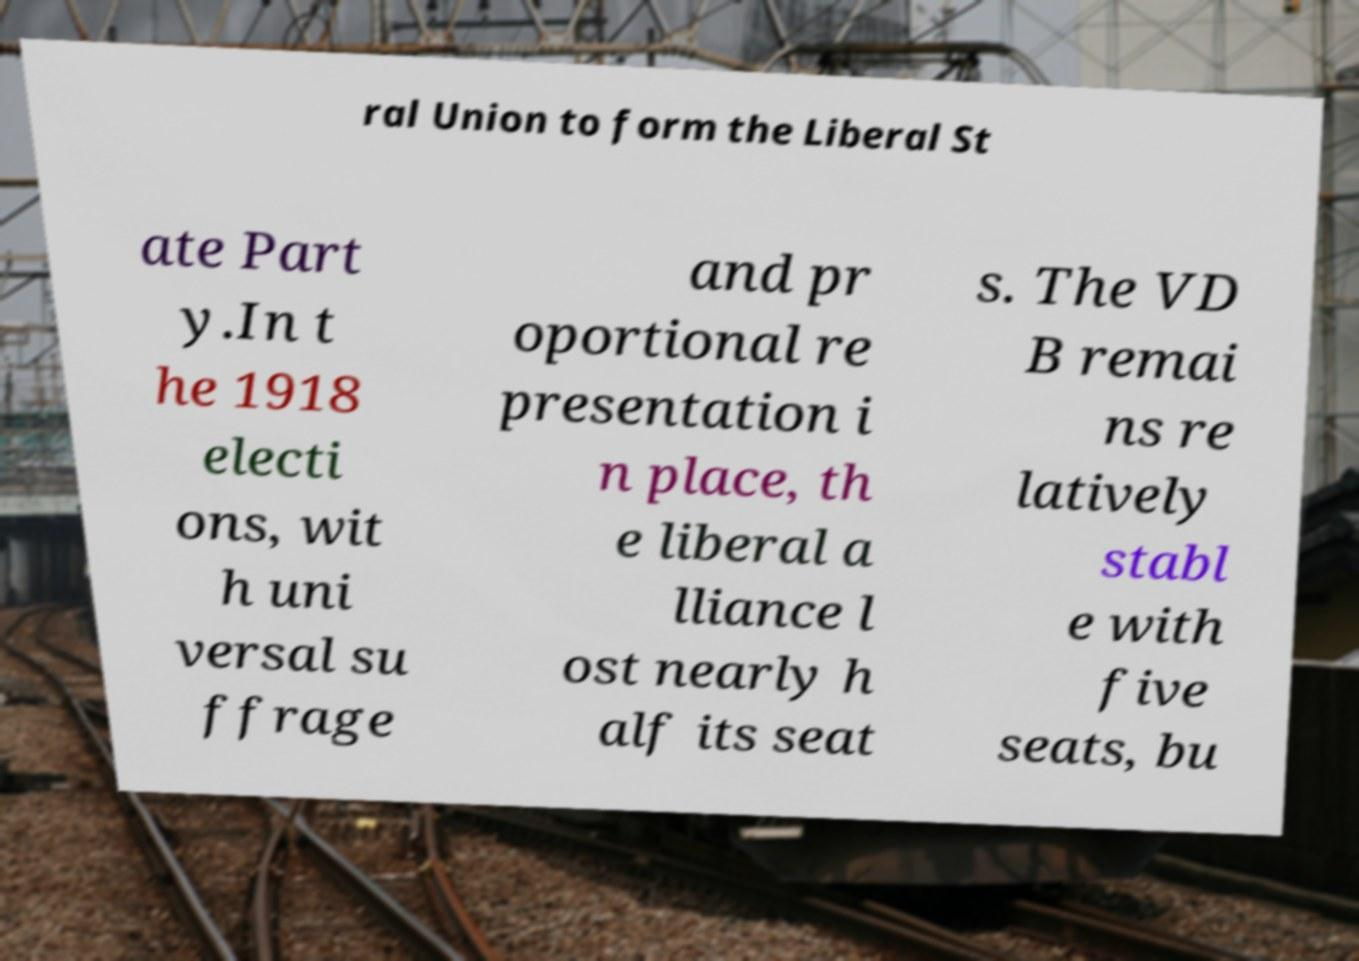Could you assist in decoding the text presented in this image and type it out clearly? ral Union to form the Liberal St ate Part y.In t he 1918 electi ons, wit h uni versal su ffrage and pr oportional re presentation i n place, th e liberal a lliance l ost nearly h alf its seat s. The VD B remai ns re latively stabl e with five seats, bu 